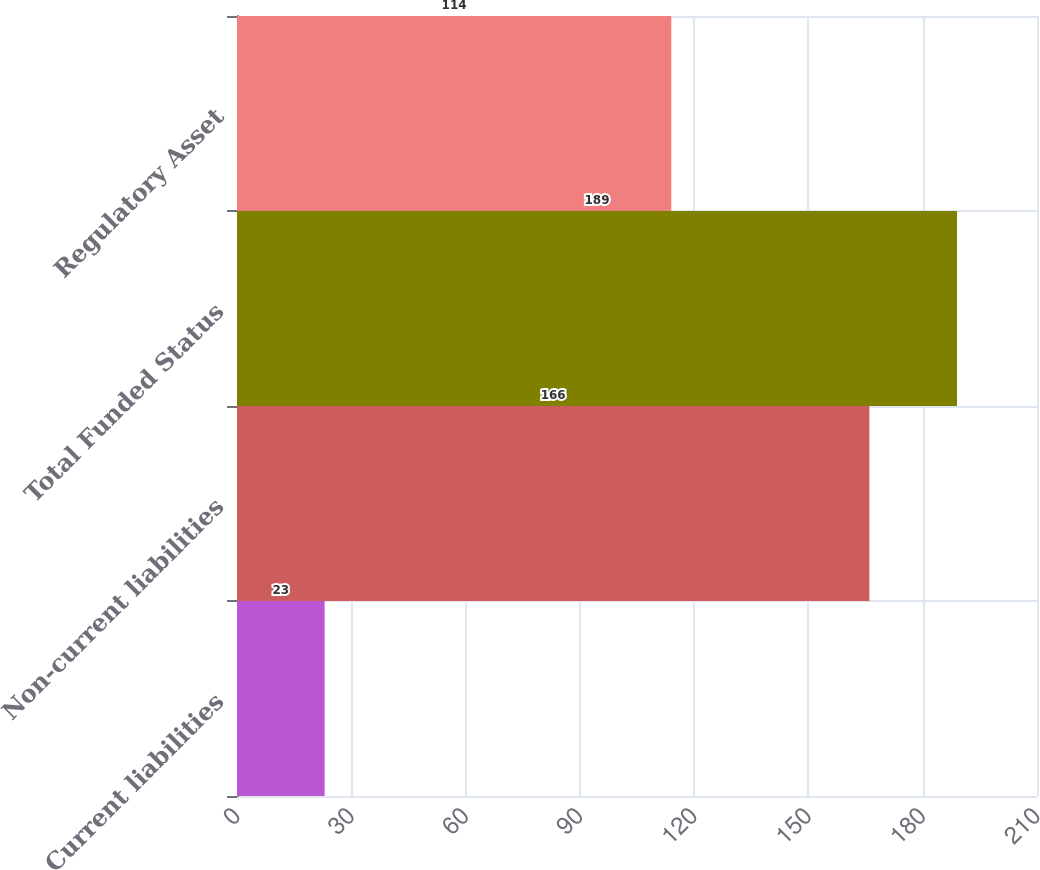Convert chart. <chart><loc_0><loc_0><loc_500><loc_500><bar_chart><fcel>Current liabilities<fcel>Non-current liabilities<fcel>Total Funded Status<fcel>Regulatory Asset<nl><fcel>23<fcel>166<fcel>189<fcel>114<nl></chart> 